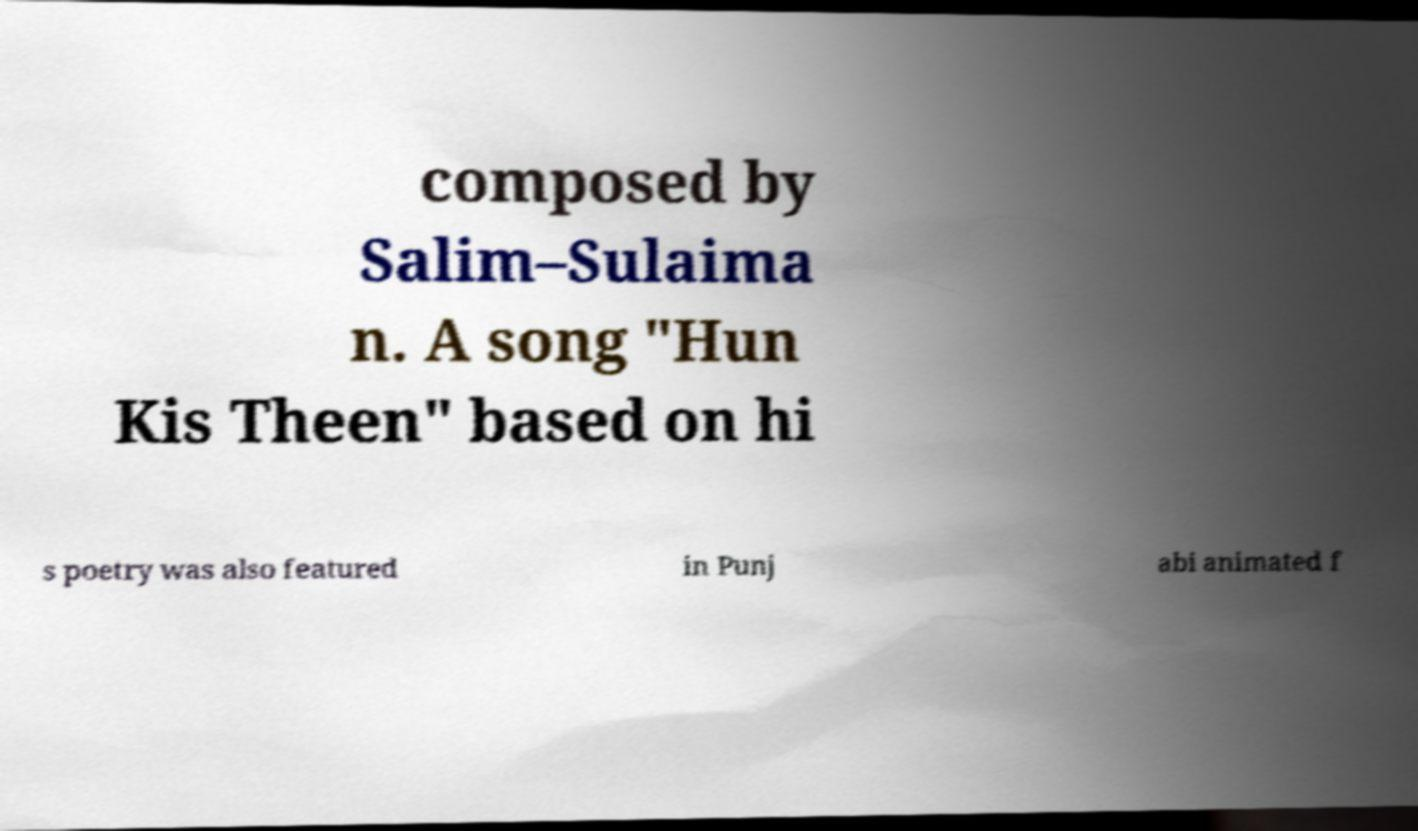Please identify and transcribe the text found in this image. composed by Salim–Sulaima n. A song "Hun Kis Theen" based on hi s poetry was also featured in Punj abi animated f 